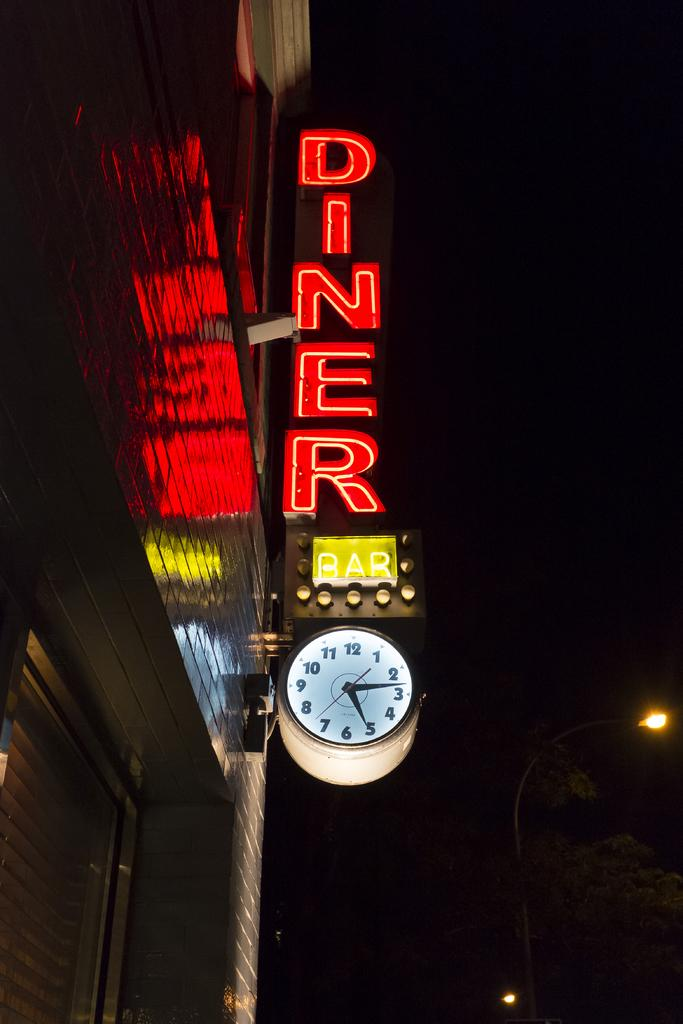<image>
Write a terse but informative summary of the picture. There's a clock beneath the diner sign that reads 5:15. 